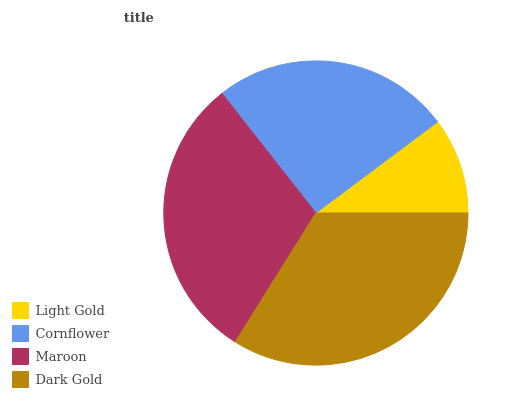Is Light Gold the minimum?
Answer yes or no. Yes. Is Dark Gold the maximum?
Answer yes or no. Yes. Is Cornflower the minimum?
Answer yes or no. No. Is Cornflower the maximum?
Answer yes or no. No. Is Cornflower greater than Light Gold?
Answer yes or no. Yes. Is Light Gold less than Cornflower?
Answer yes or no. Yes. Is Light Gold greater than Cornflower?
Answer yes or no. No. Is Cornflower less than Light Gold?
Answer yes or no. No. Is Maroon the high median?
Answer yes or no. Yes. Is Cornflower the low median?
Answer yes or no. Yes. Is Light Gold the high median?
Answer yes or no. No. Is Light Gold the low median?
Answer yes or no. No. 